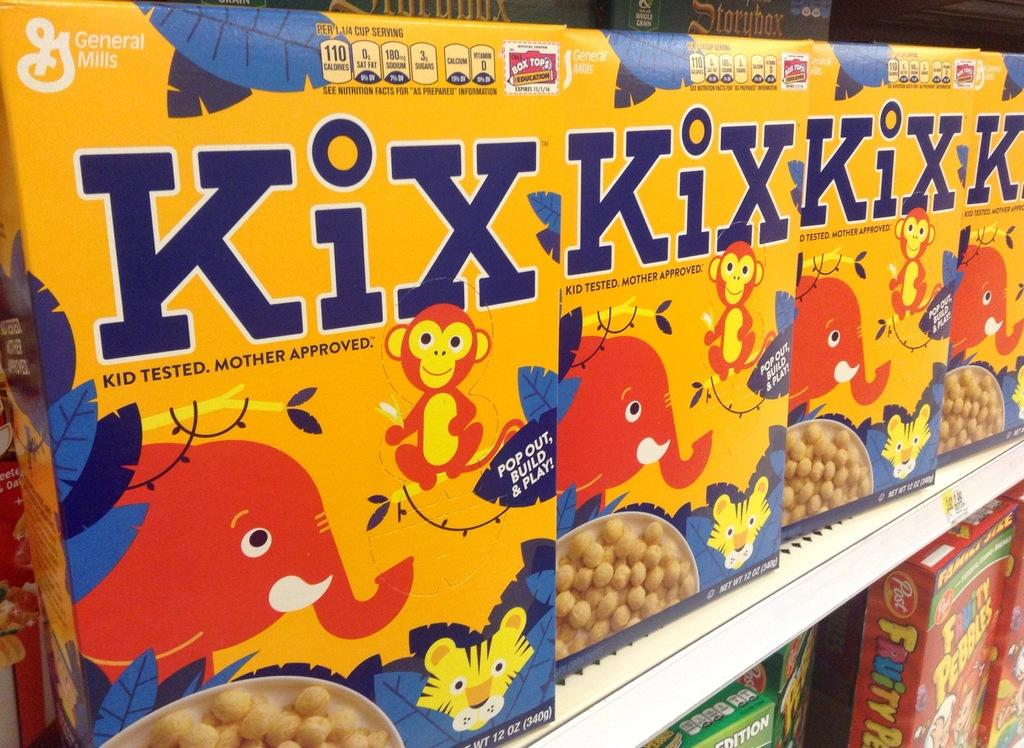What type of product is featured in the image? There are cereal packets for kids in the image. How are the cereal packets arranged? The cereal packets are arranged in an order. Where are the cereal packets placed? The cereal packets are placed in a rack. Is there any additional decoration or information on the rack? Yes, there is a sticker attached to the rack. What type of bird can be seen sitting on the doll in the image? There is no bird or doll present in the image; it features cereal packets arranged in a rack with a sticker attached. 